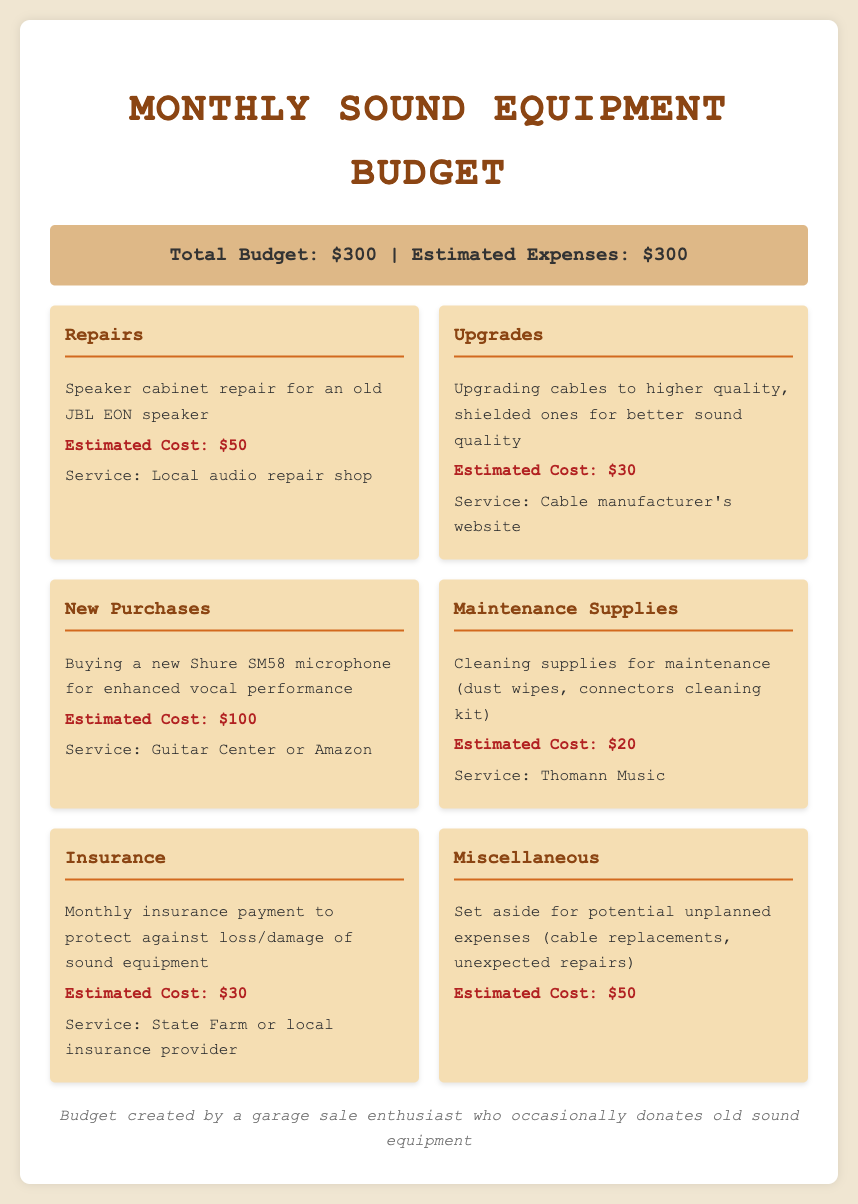What is the total budget? The total budget is stated at the top of the document.
Answer: $300 What is the estimated cost for repairs? The estimated cost for repairs is detailed in the "Repairs" section of the document.
Answer: $50 What type of microphone is being purchased? The microphone being purchased is mentioned in the "New Purchases" section.
Answer: Shure SM58 How much is allocated for maintenance supplies? The allocation for maintenance supplies is provided under that specific category.
Answer: $20 What is the service provider for insurance? The insurance service providers are mentioned alongside the insurance cost.
Answer: State Farm or local insurance provider What is the total estimated expense? The total estimated expense is stated immediately next to the total budget in the summary.
Answer: $300 How much is set aside for miscellaneous expenses? The amount set aside for miscellaneous expenses can be found in the "Miscellaneous" section.
Answer: $50 What is the estimated cost for upgrading cables? The cost for upgrading cables is noted in the "Upgrades" category of the budget.
Answer: $30 What product is being upgraded? The upgraded product is identified in the "Upgrades" section of the document.
Answer: Cables 